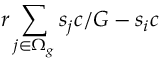Convert formula to latex. <formula><loc_0><loc_0><loc_500><loc_500>r \sum _ { j \in \Omega _ { g } } s _ { j } c / G - s _ { i } c</formula> 